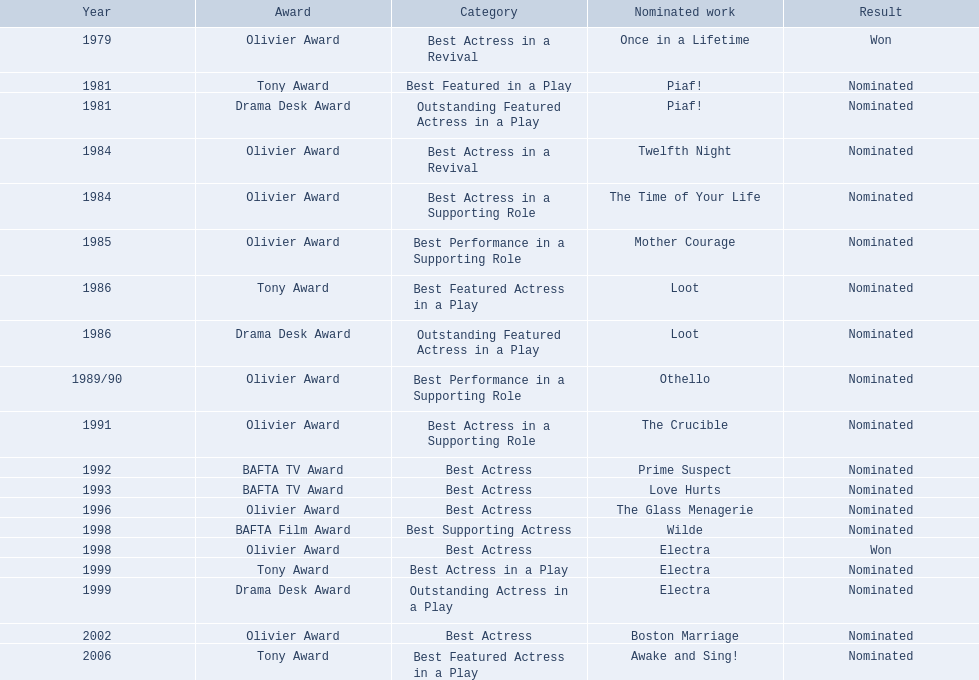What were all the nominated works that included zoe wanamaker? Once in a Lifetime, Piaf!, Piaf!, Twelfth Night, The Time of Your Life, Mother Courage, Loot, Loot, Othello, The Crucible, Prime Suspect, Love Hurts, The Glass Menagerie, Wilde, Electra, Electra, Electra, Boston Marriage, Awake and Sing!. In which years were these nominations given? 1979, 1981, 1981, 1984, 1984, 1985, 1986, 1986, 1989/90, 1991, 1992, 1993, 1996, 1998, 1998, 1999, 1999, 2002, 2006. In 1984, which categories was she nominated for? Best Actress in a Revival. For which work was this nomination granted? Twelfth Night. 